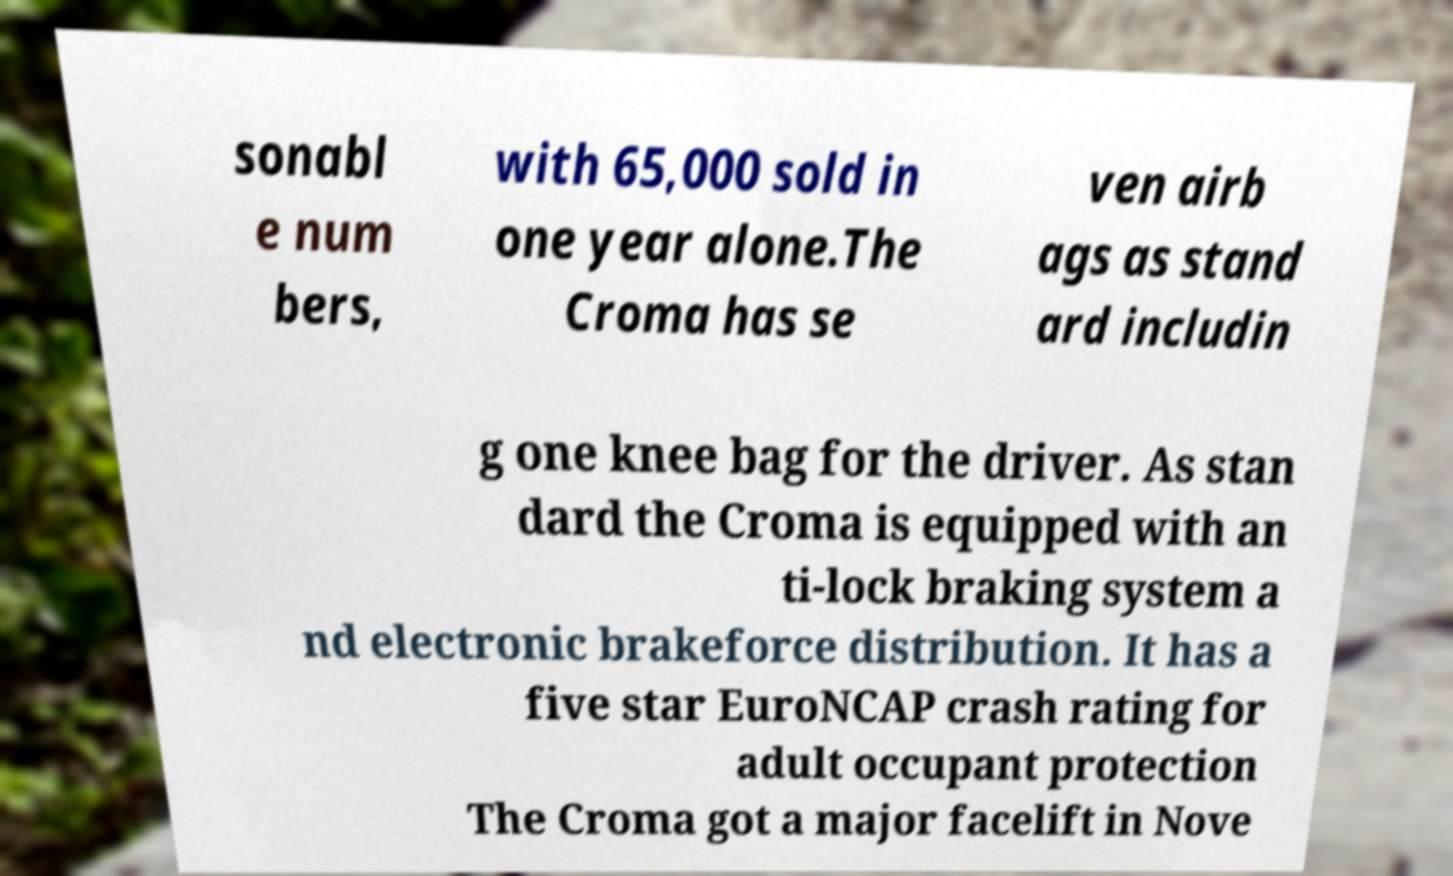There's text embedded in this image that I need extracted. Can you transcribe it verbatim? sonabl e num bers, with 65,000 sold in one year alone.The Croma has se ven airb ags as stand ard includin g one knee bag for the driver. As stan dard the Croma is equipped with an ti-lock braking system a nd electronic brakeforce distribution. It has a five star EuroNCAP crash rating for adult occupant protection The Croma got a major facelift in Nove 